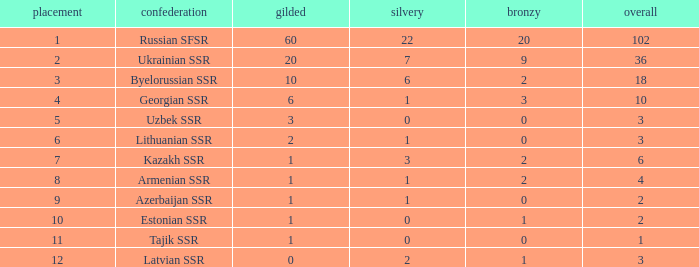What is the sum of silvers for teams with ranks over 3 and totals under 2? 0.0. 